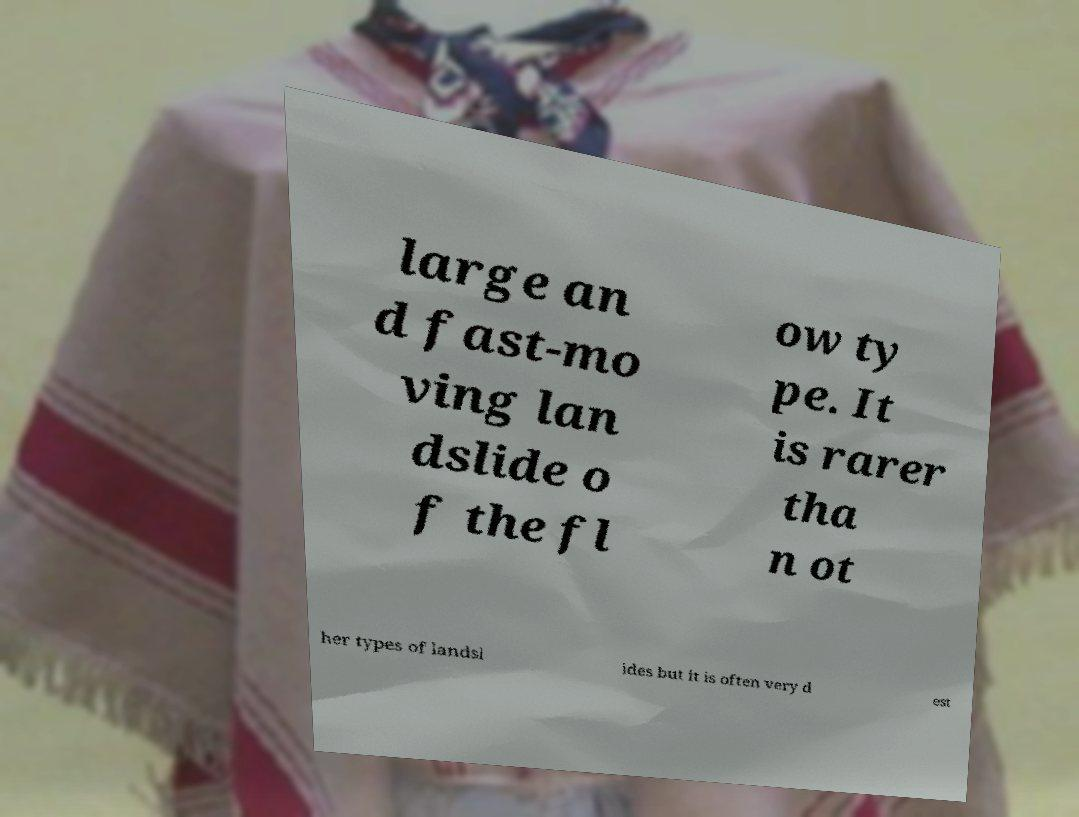I need the written content from this picture converted into text. Can you do that? large an d fast-mo ving lan dslide o f the fl ow ty pe. It is rarer tha n ot her types of landsl ides but it is often very d est 